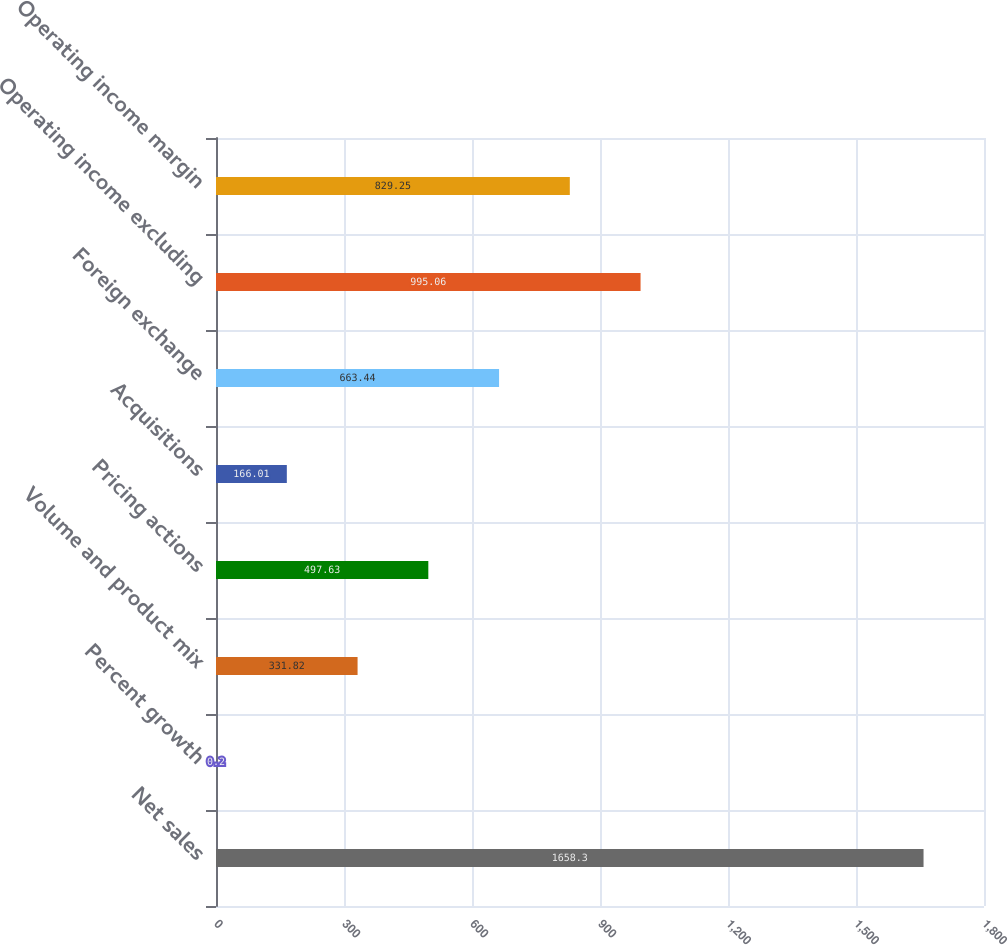Convert chart. <chart><loc_0><loc_0><loc_500><loc_500><bar_chart><fcel>Net sales<fcel>Percent growth<fcel>Volume and product mix<fcel>Pricing actions<fcel>Acquisitions<fcel>Foreign exchange<fcel>Operating income excluding<fcel>Operating income margin<nl><fcel>1658.3<fcel>0.2<fcel>331.82<fcel>497.63<fcel>166.01<fcel>663.44<fcel>995.06<fcel>829.25<nl></chart> 